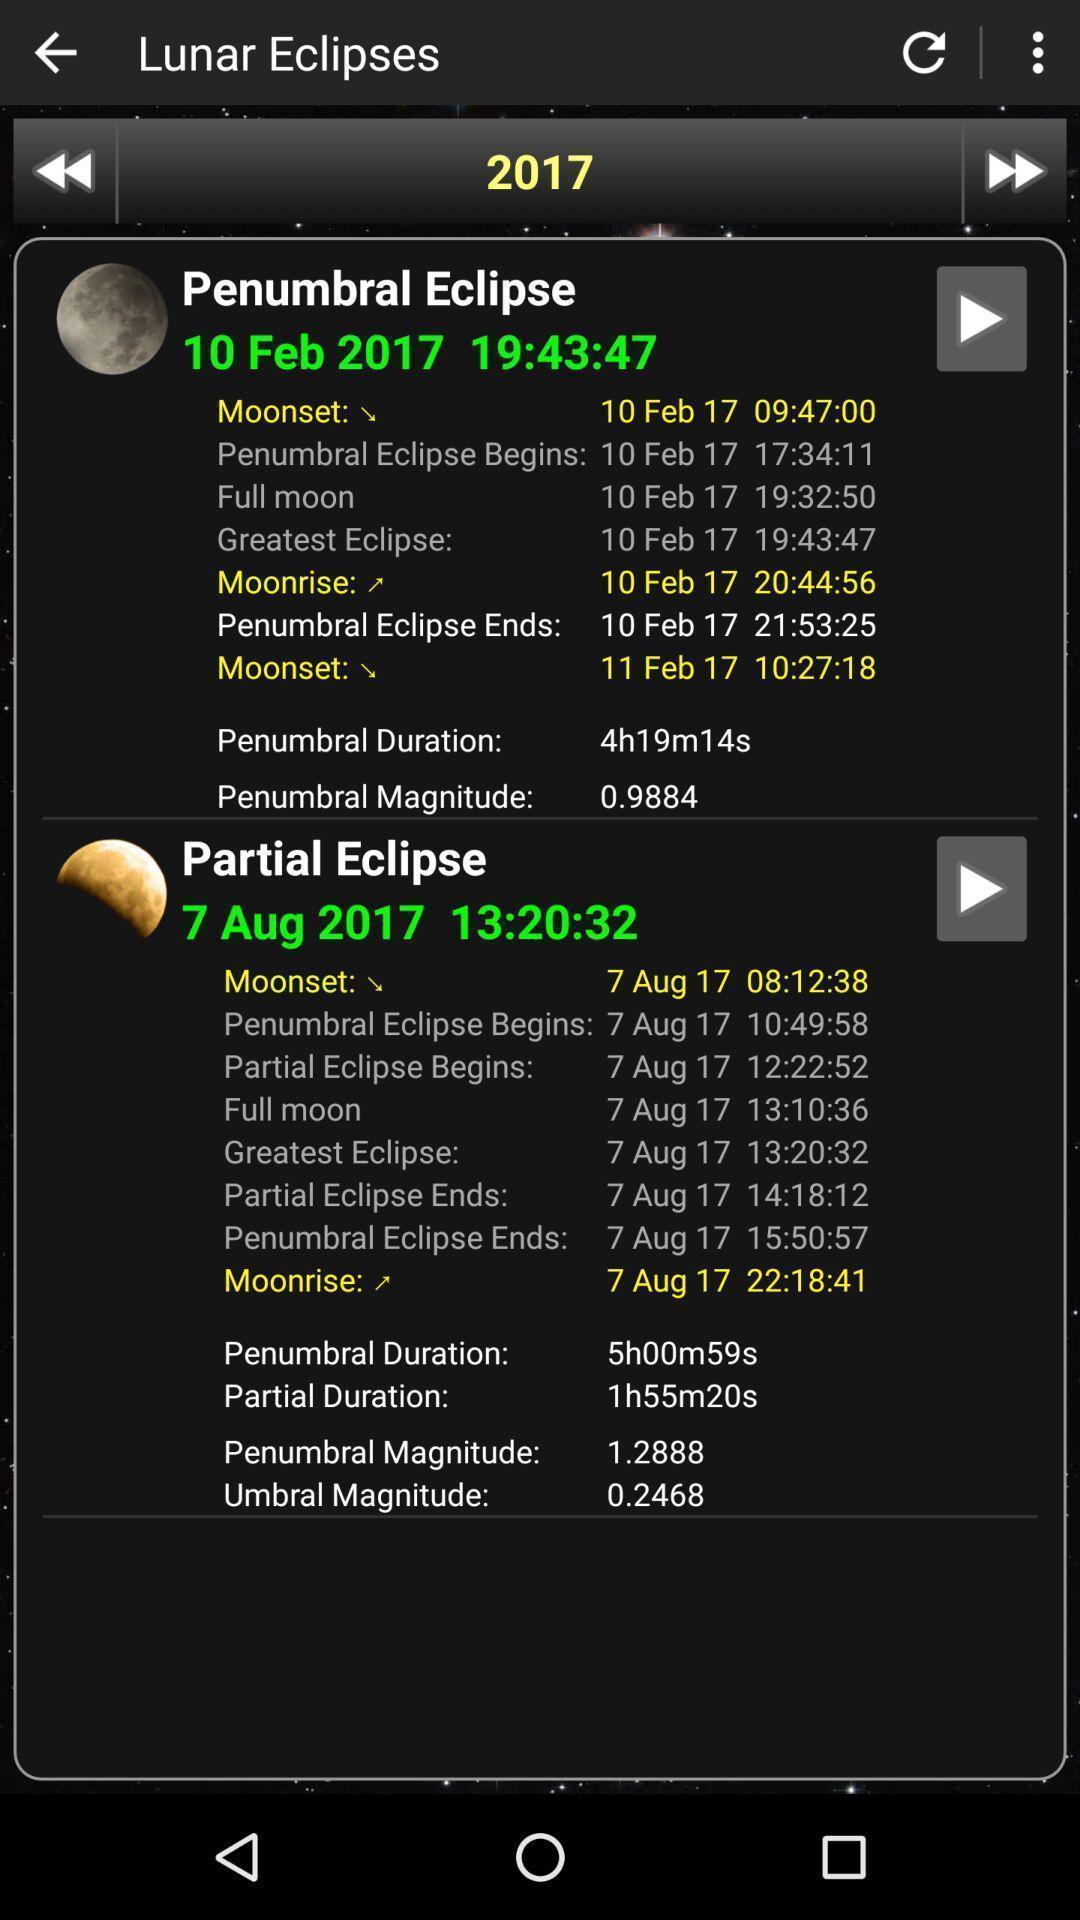Summarize the information in this screenshot. Page showing about different eclipse. 